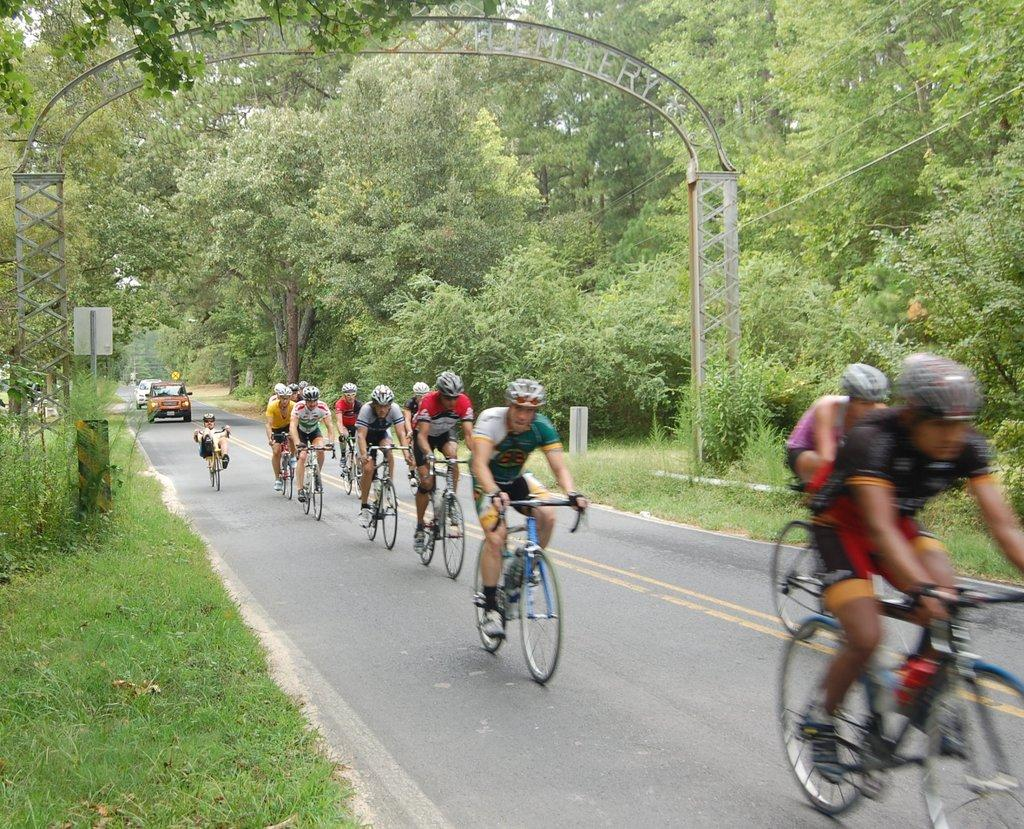What activity are the people in the image engaged in? The people in the image are riding bicycles. What else can be seen on the road in the image? There are vehicles on the road in the image. What type of vegetation is present in the image? There are plants and trees in the image. What architectural feature can be seen in the image? There is an arch in the image. Where is the toothbrush located in the image? There is no toothbrush present in the image. What type of quiver is being used by the bicycle riders in the image? There is no quiver present in the image; the people are riding bicycles, not using any archery equipment. 